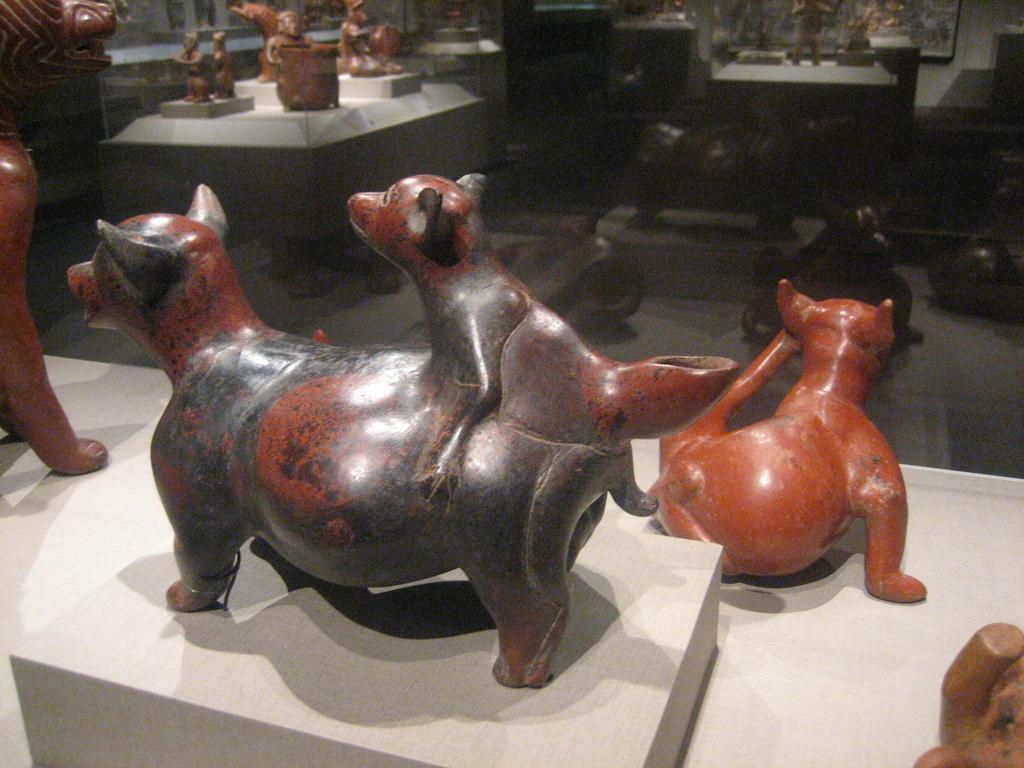Describe this image in one or two sentences. In this image we can see a sculptures placed on a surface and in the background, we can see different types of sculptures are placed on a surface. 